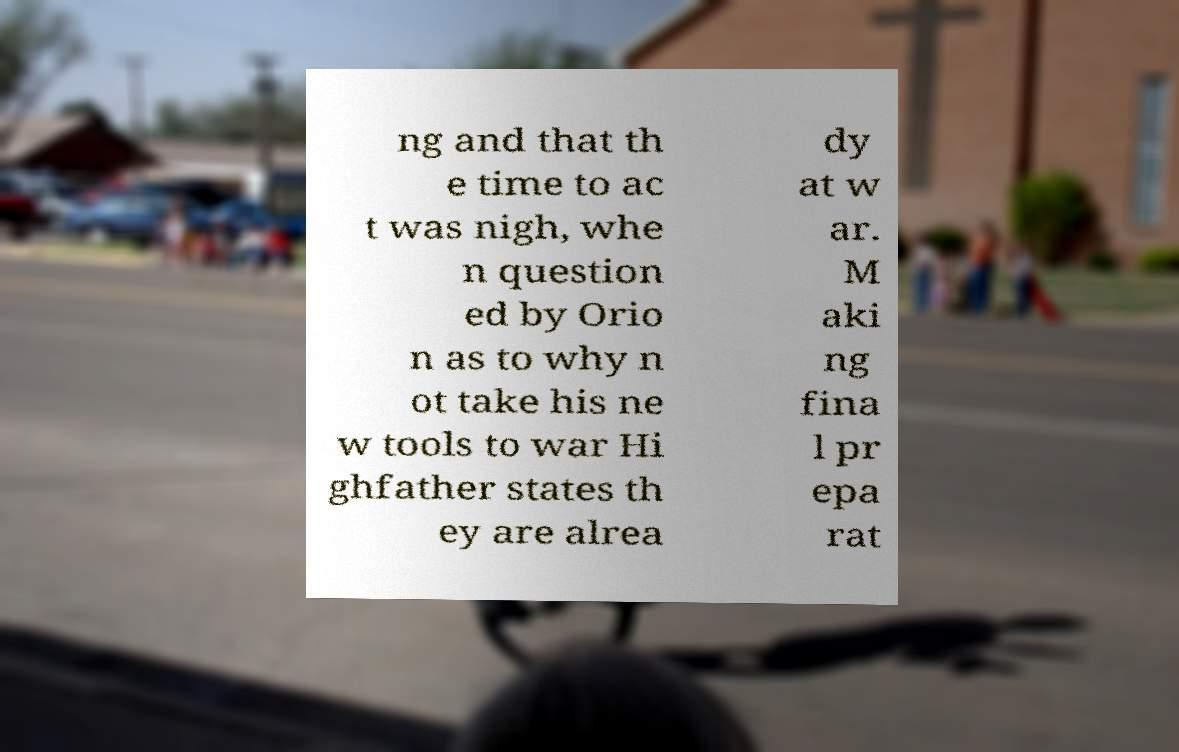There's text embedded in this image that I need extracted. Can you transcribe it verbatim? ng and that th e time to ac t was nigh, whe n question ed by Orio n as to why n ot take his ne w tools to war Hi ghfather states th ey are alrea dy at w ar. M aki ng fina l pr epa rat 